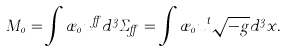<formula> <loc_0><loc_0><loc_500><loc_500>M _ { 0 } = \int \rho _ { 0 } u ^ { \alpha } d ^ { 3 } \Sigma _ { \alpha } = \int \rho _ { 0 } u ^ { t } \sqrt { - g } d ^ { 3 } x .</formula> 